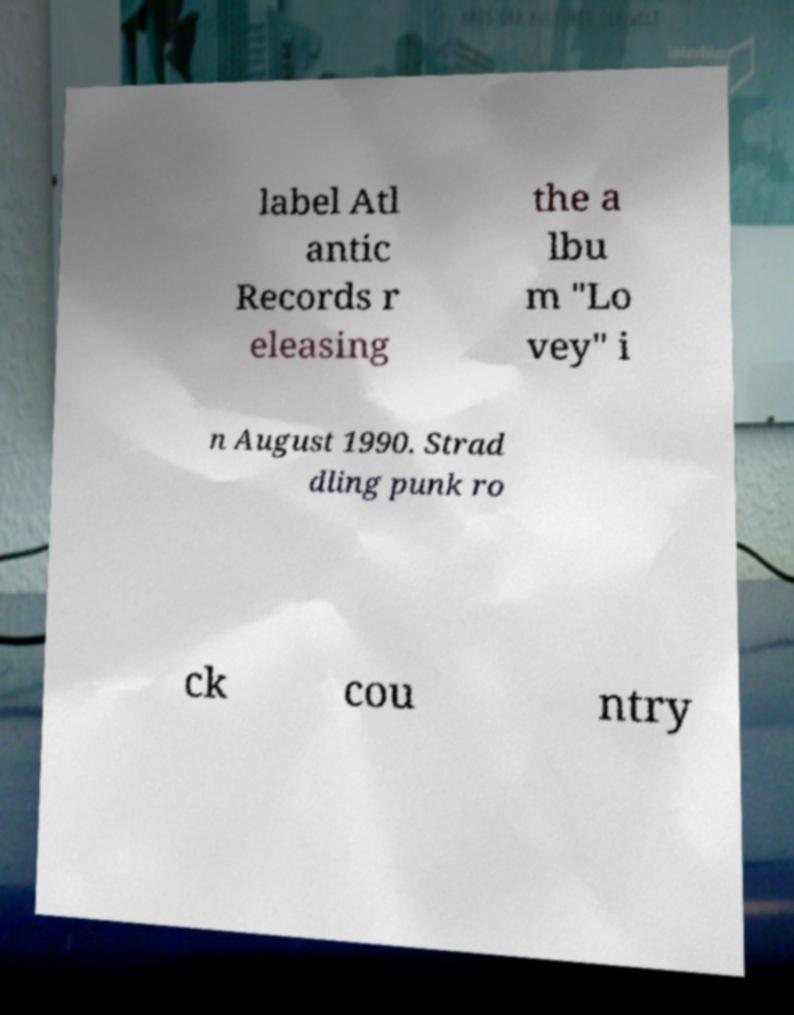Please identify and transcribe the text found in this image. label Atl antic Records r eleasing the a lbu m "Lo vey" i n August 1990. Strad dling punk ro ck cou ntry 